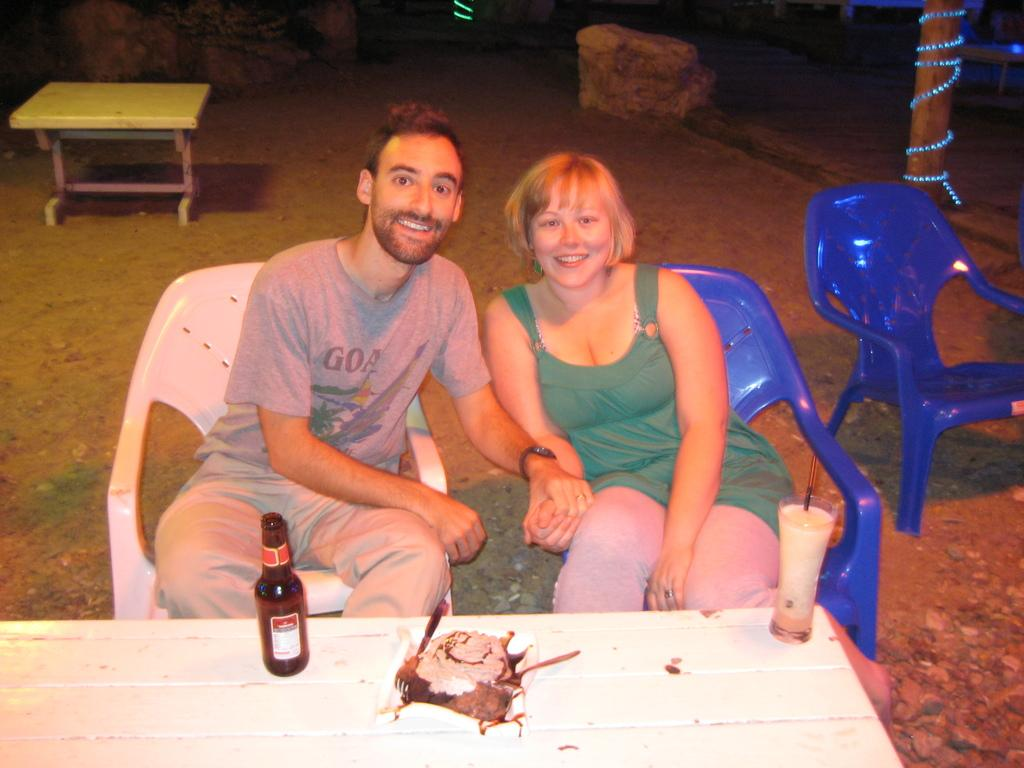Who is present in the image? There is a couple in the image. What are the couple doing in the image? The couple is posing for a camera. How are the couple positioned in the image? The couple is sitting in chairs. What objects can be seen on the table in the image? There is a bottle, a plate with food, and a glass on the table. What type of frame is hanging on the wall behind the couple in the image? There is no frame visible in the image; it only shows a couple sitting in chairs, posing for a camera, and a table with objects on it. 